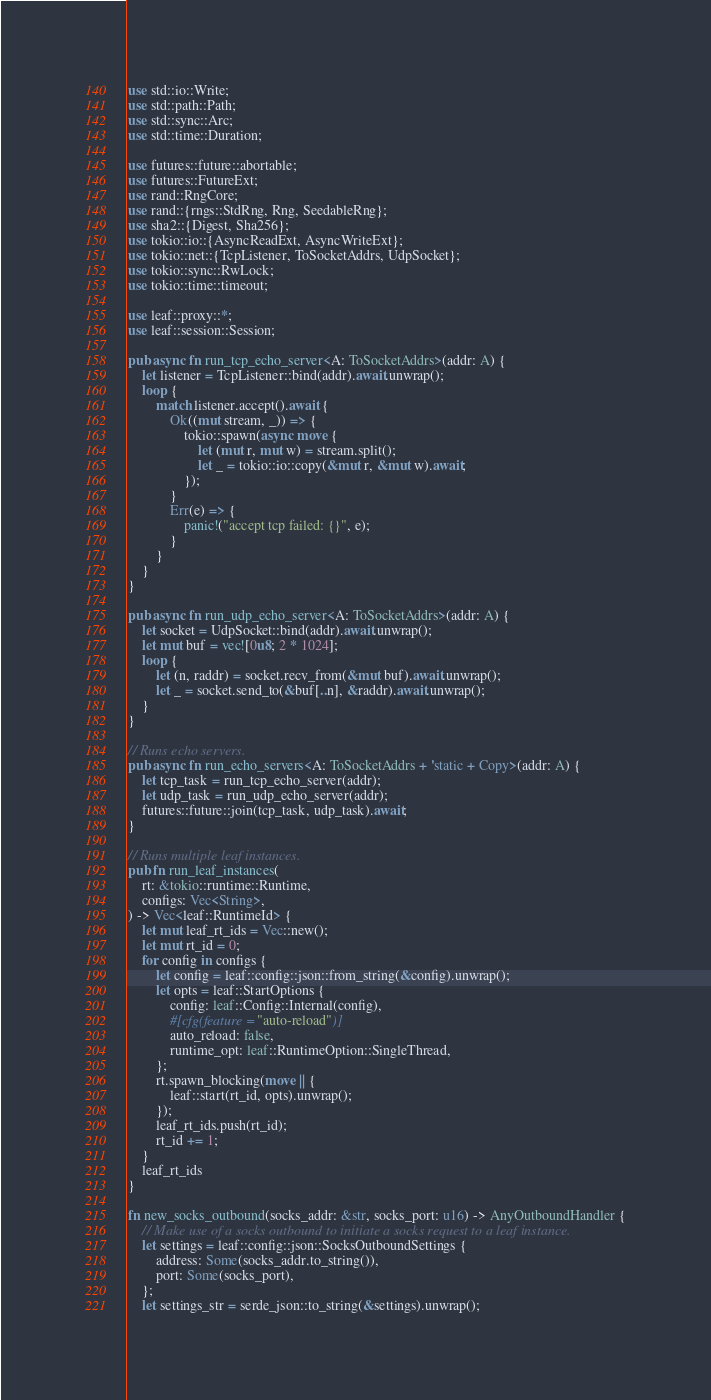<code> <loc_0><loc_0><loc_500><loc_500><_Rust_>use std::io::Write;
use std::path::Path;
use std::sync::Arc;
use std::time::Duration;

use futures::future::abortable;
use futures::FutureExt;
use rand::RngCore;
use rand::{rngs::StdRng, Rng, SeedableRng};
use sha2::{Digest, Sha256};
use tokio::io::{AsyncReadExt, AsyncWriteExt};
use tokio::net::{TcpListener, ToSocketAddrs, UdpSocket};
use tokio::sync::RwLock;
use tokio::time::timeout;

use leaf::proxy::*;
use leaf::session::Session;

pub async fn run_tcp_echo_server<A: ToSocketAddrs>(addr: A) {
    let listener = TcpListener::bind(addr).await.unwrap();
    loop {
        match listener.accept().await {
            Ok((mut stream, _)) => {
                tokio::spawn(async move {
                    let (mut r, mut w) = stream.split();
                    let _ = tokio::io::copy(&mut r, &mut w).await;
                });
            }
            Err(e) => {
                panic!("accept tcp failed: {}", e);
            }
        }
    }
}

pub async fn run_udp_echo_server<A: ToSocketAddrs>(addr: A) {
    let socket = UdpSocket::bind(addr).await.unwrap();
    let mut buf = vec![0u8; 2 * 1024];
    loop {
        let (n, raddr) = socket.recv_from(&mut buf).await.unwrap();
        let _ = socket.send_to(&buf[..n], &raddr).await.unwrap();
    }
}

// Runs echo servers.
pub async fn run_echo_servers<A: ToSocketAddrs + 'static + Copy>(addr: A) {
    let tcp_task = run_tcp_echo_server(addr);
    let udp_task = run_udp_echo_server(addr);
    futures::future::join(tcp_task, udp_task).await;
}

// Runs multiple leaf instances.
pub fn run_leaf_instances(
    rt: &tokio::runtime::Runtime,
    configs: Vec<String>,
) -> Vec<leaf::RuntimeId> {
    let mut leaf_rt_ids = Vec::new();
    let mut rt_id = 0;
    for config in configs {
        let config = leaf::config::json::from_string(&config).unwrap();
        let opts = leaf::StartOptions {
            config: leaf::Config::Internal(config),
            #[cfg(feature = "auto-reload")]
            auto_reload: false,
            runtime_opt: leaf::RuntimeOption::SingleThread,
        };
        rt.spawn_blocking(move || {
            leaf::start(rt_id, opts).unwrap();
        });
        leaf_rt_ids.push(rt_id);
        rt_id += 1;
    }
    leaf_rt_ids
}

fn new_socks_outbound(socks_addr: &str, socks_port: u16) -> AnyOutboundHandler {
    // Make use of a socks outbound to initiate a socks request to a leaf instance.
    let settings = leaf::config::json::SocksOutboundSettings {
        address: Some(socks_addr.to_string()),
        port: Some(socks_port),
    };
    let settings_str = serde_json::to_string(&settings).unwrap();</code> 